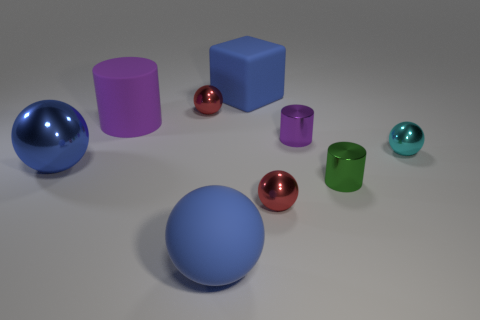Are there any purple cubes that have the same material as the big purple object?
Make the answer very short. No. The thing that is the same color as the rubber cylinder is what size?
Give a very brief answer. Small. What is the color of the tiny ball in front of the large shiny object?
Provide a succinct answer. Red. There is a tiny green metallic object; is it the same shape as the tiny red thing that is behind the tiny purple shiny cylinder?
Your answer should be very brief. No. Are there any objects that have the same color as the large cylinder?
Your answer should be compact. Yes. What size is the purple cylinder that is the same material as the block?
Provide a short and direct response. Large. Is the color of the matte ball the same as the big rubber cylinder?
Offer a very short reply. No. Does the cyan shiny thing that is behind the large blue metallic thing have the same shape as the large shiny thing?
Provide a short and direct response. Yes. What number of purple cylinders are the same size as the green object?
Make the answer very short. 1. What shape is the large rubber thing that is the same color as the matte sphere?
Provide a succinct answer. Cube. 